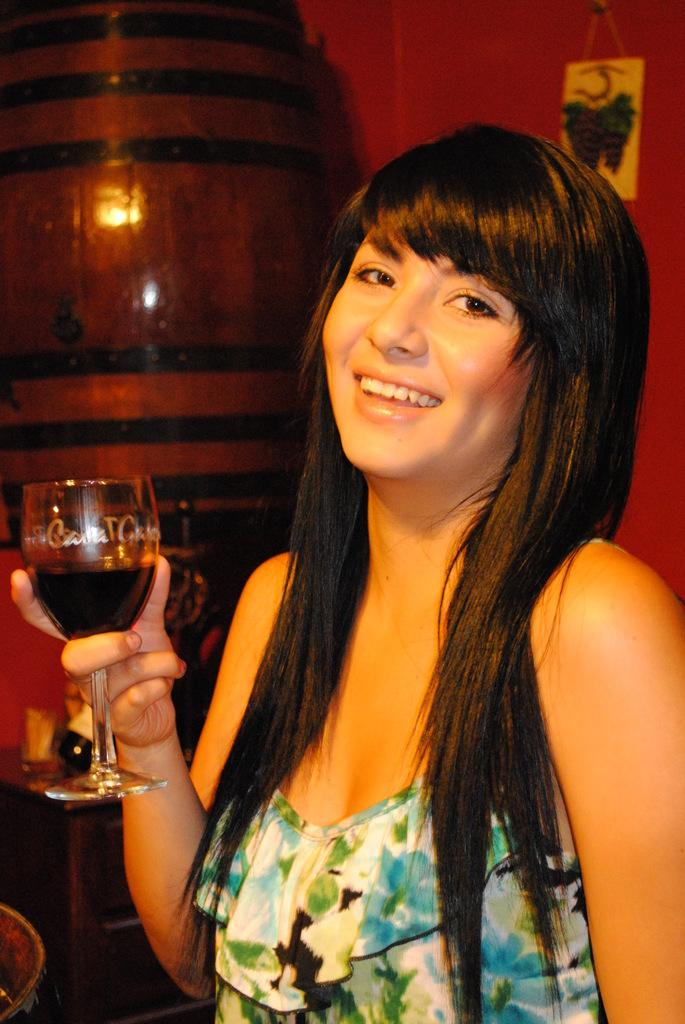What is the person holding in the image? The person is holding a glass. What is the expression on the person's face? The person is smiling. What can be seen in the background of the image? There is a wall and a poster in the background. Are there any objects visible on a table in the background? Yes, there are objects on a table in the background. What type of team is the person a part of in the image? There is no indication of a team in the image; it only shows a person holding a glass and smiling. 